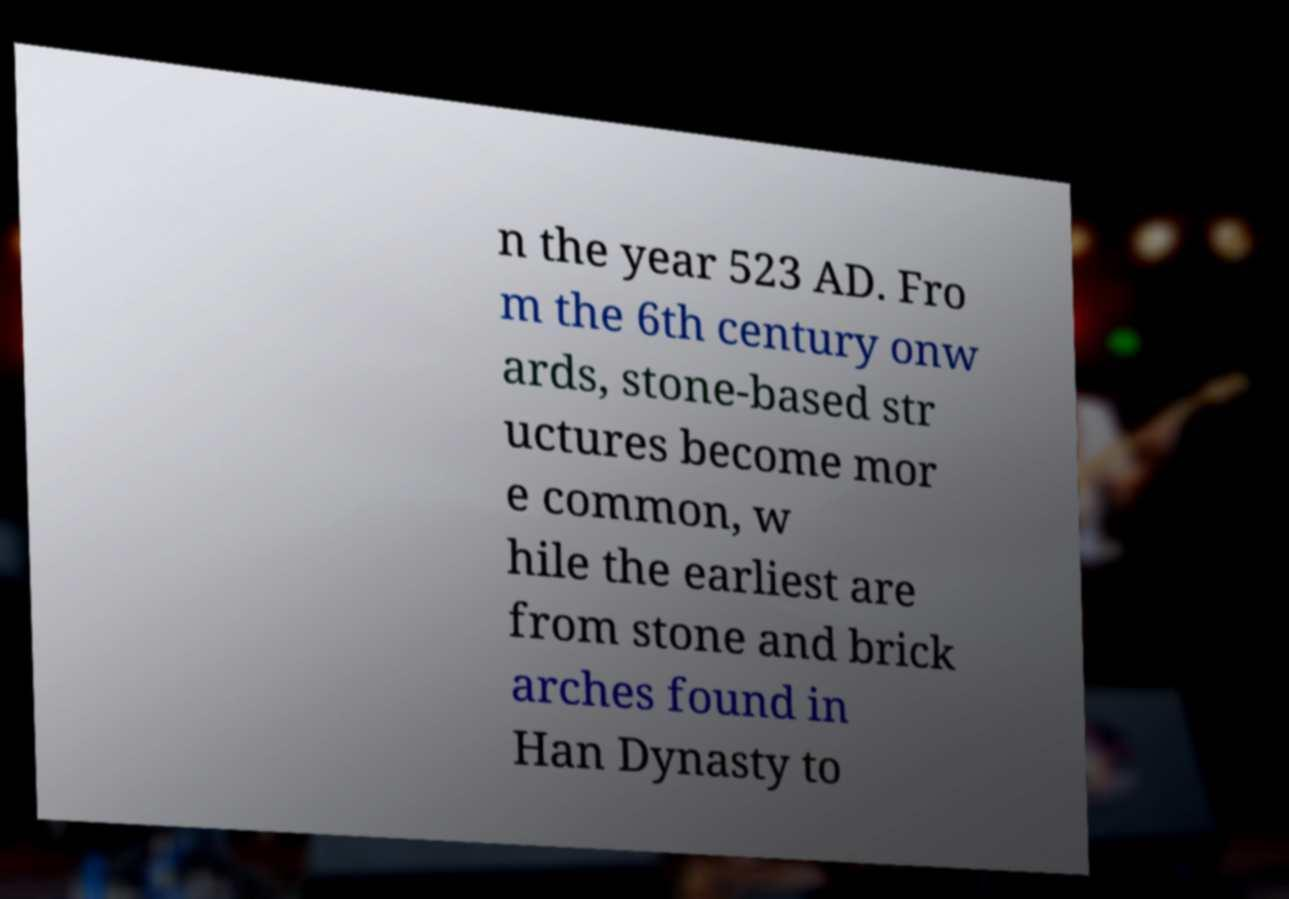Can you read and provide the text displayed in the image?This photo seems to have some interesting text. Can you extract and type it out for me? n the year 523 AD. Fro m the 6th century onw ards, stone-based str uctures become mor e common, w hile the earliest are from stone and brick arches found in Han Dynasty to 